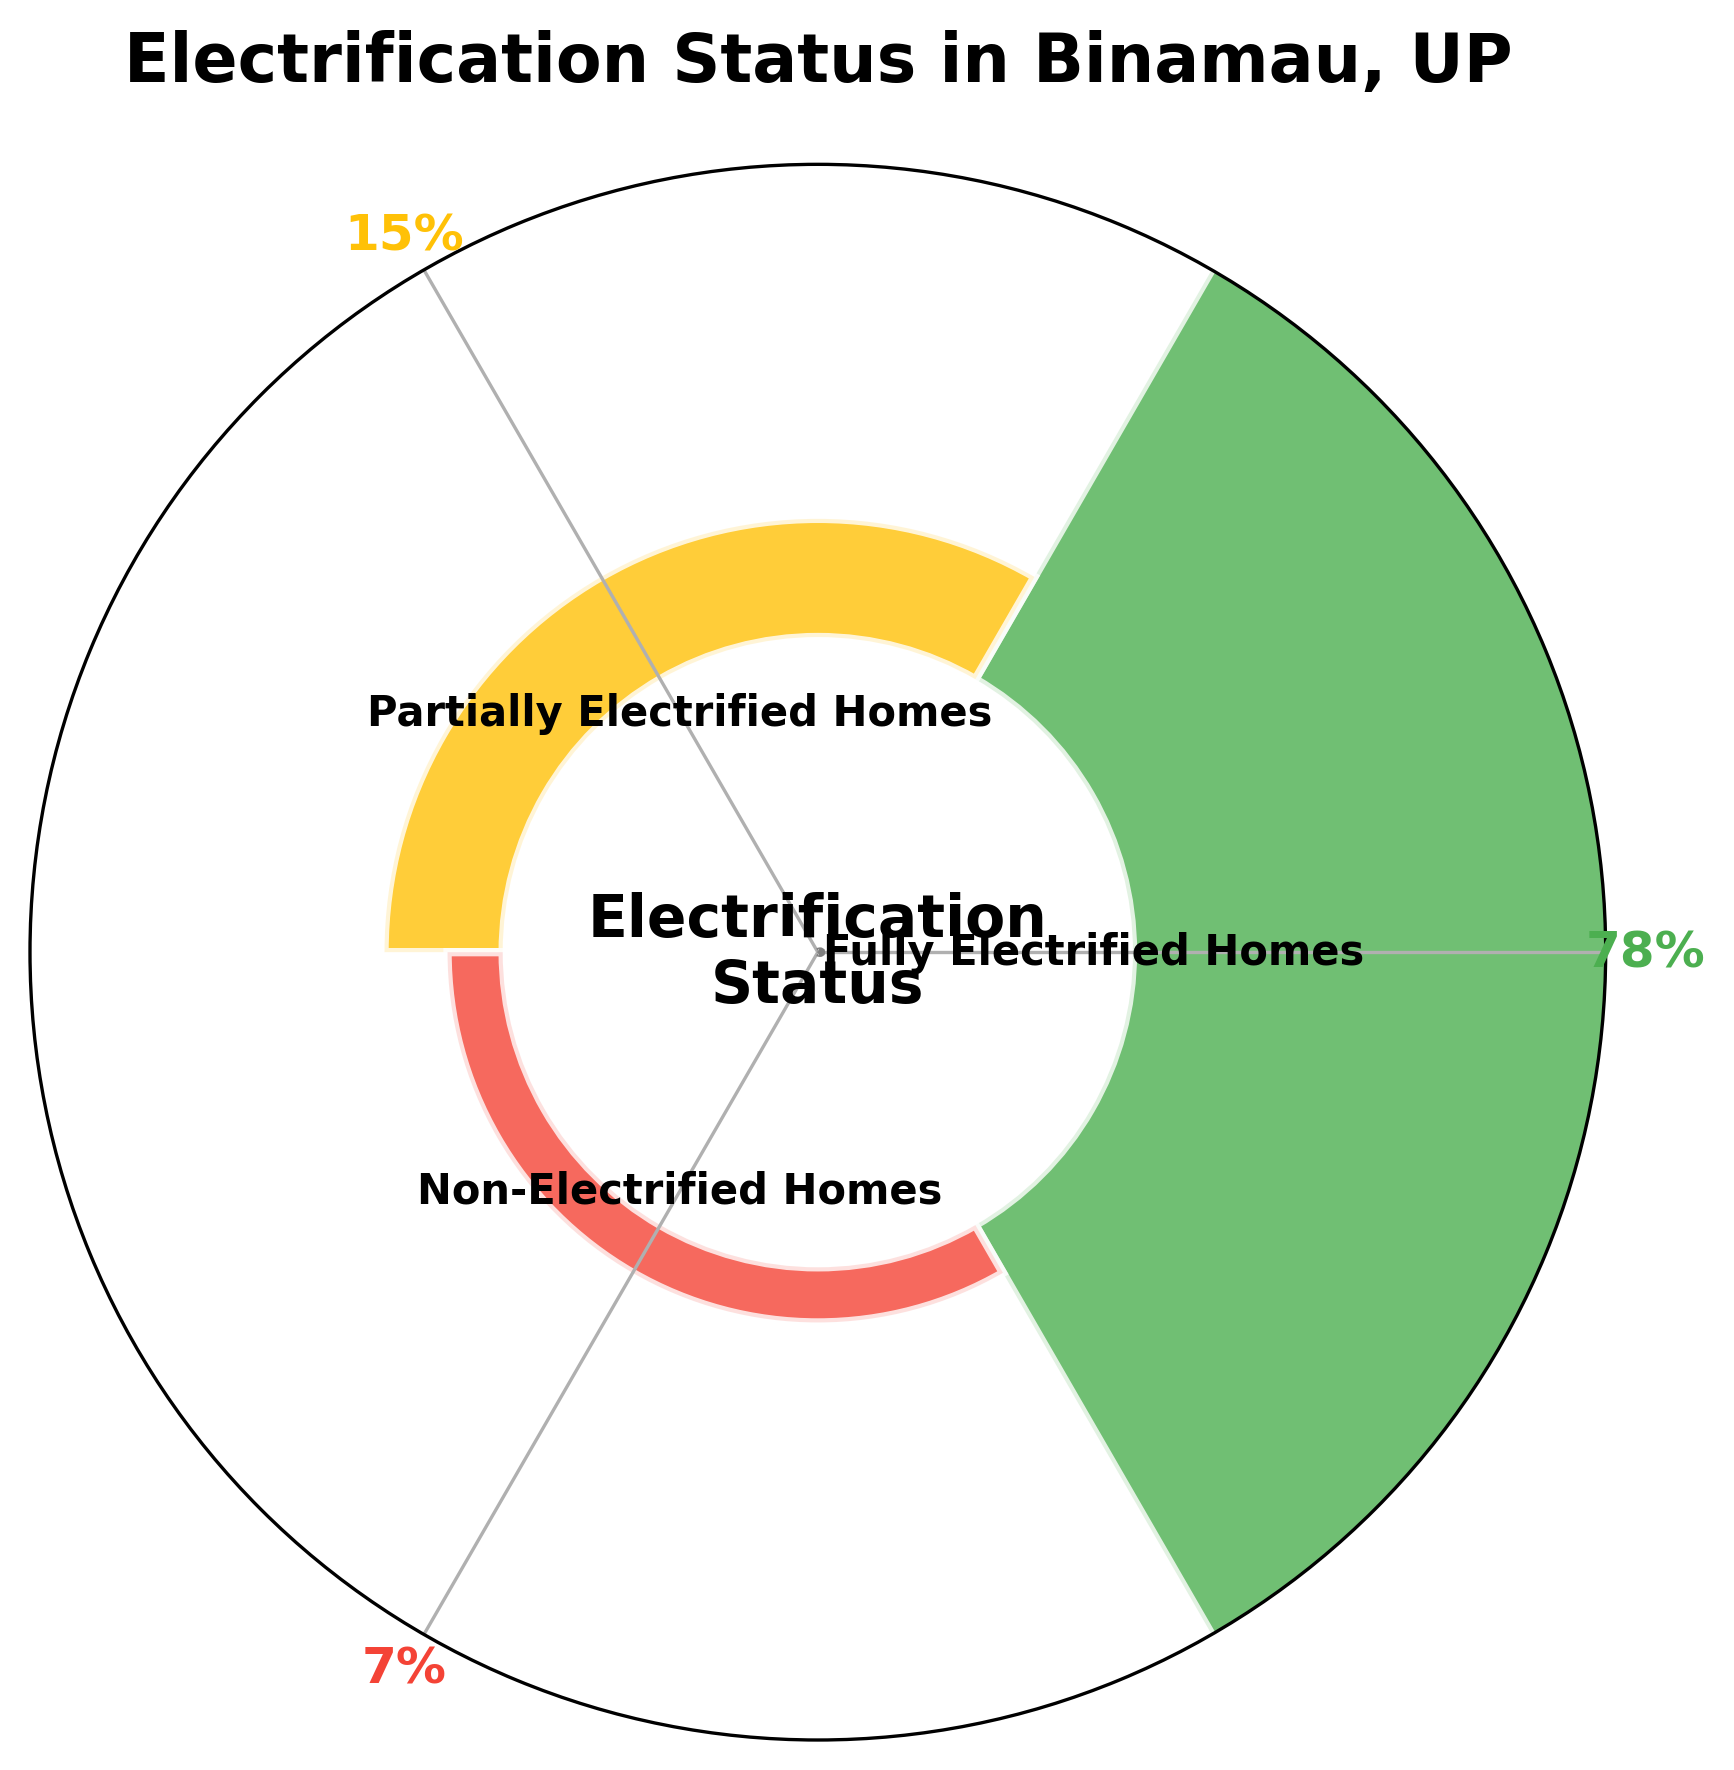What is the title of the plot? The title of the plot is typically found at the top and is used to describe the main topic of the plot. Here, it appears prominently at the top of the visual.
Answer: Electrification Status in Binamau, UP How many categories of electrification status are represented in the plot? By examining the number of different colored segments and the labels associated with them, we can determine the number of categories.
Answer: 3 Which category has the highest percentage of homes? By looking at the size of the segments and reading the percentage value next to each category label, we can determine the one with the highest percentage.
Answer: Fully Electrified Homes What percentage of homes are non-electrified? By locating the segment labeled "Non-Electrified Homes" and reading the percentage value associated with it, we can find the answer.
Answer: 7% What is the combined percentage of fully and partially electrified homes? By adding the percentages of "Fully Electrified Homes" and "Partially Electrified Homes," we get the combined percentage.
Answer: 78% + 15% = 93 Are there more homes that are partially electrified or non-electrified? Comparing the percentage values of the "Partially Electrified Homes" and "Non-Electrified Homes" will reveal which category has more homes.
Answer: Partially Electrified Homes What color represents the fully electrified homes category? By identifying the segment labeled "Fully Electrified Homes" and noting its color, we find this information.
Answer: Green What is the gap between fully electrified and partially electrified homes? Subtracting the percentage of "Partially Electrified Homes" from "Fully Electrified Homes" gives the difference between these categories.
Answer: 78% - 15% = 63% How does the percentage of fully electrified homes compare to the total percentage of homes that are not fully electrified (partially + non-electrified)? First, sum the percentages of "Partially Electrified Homes" and "Non-Electrified Homes," then compare this total to the percentage of "Fully Electrified Homes."
Answer: 78% vs (15% + 7% = 22%) What portion of the homes are non-fully electrified (either partially or non-electrified)? Summing the percentages of "Partially Electrified Homes" and "Non-Electrified Homes" provides the portion of homes that are not fully electrified.
Answer: 15% + 7% = 22% 